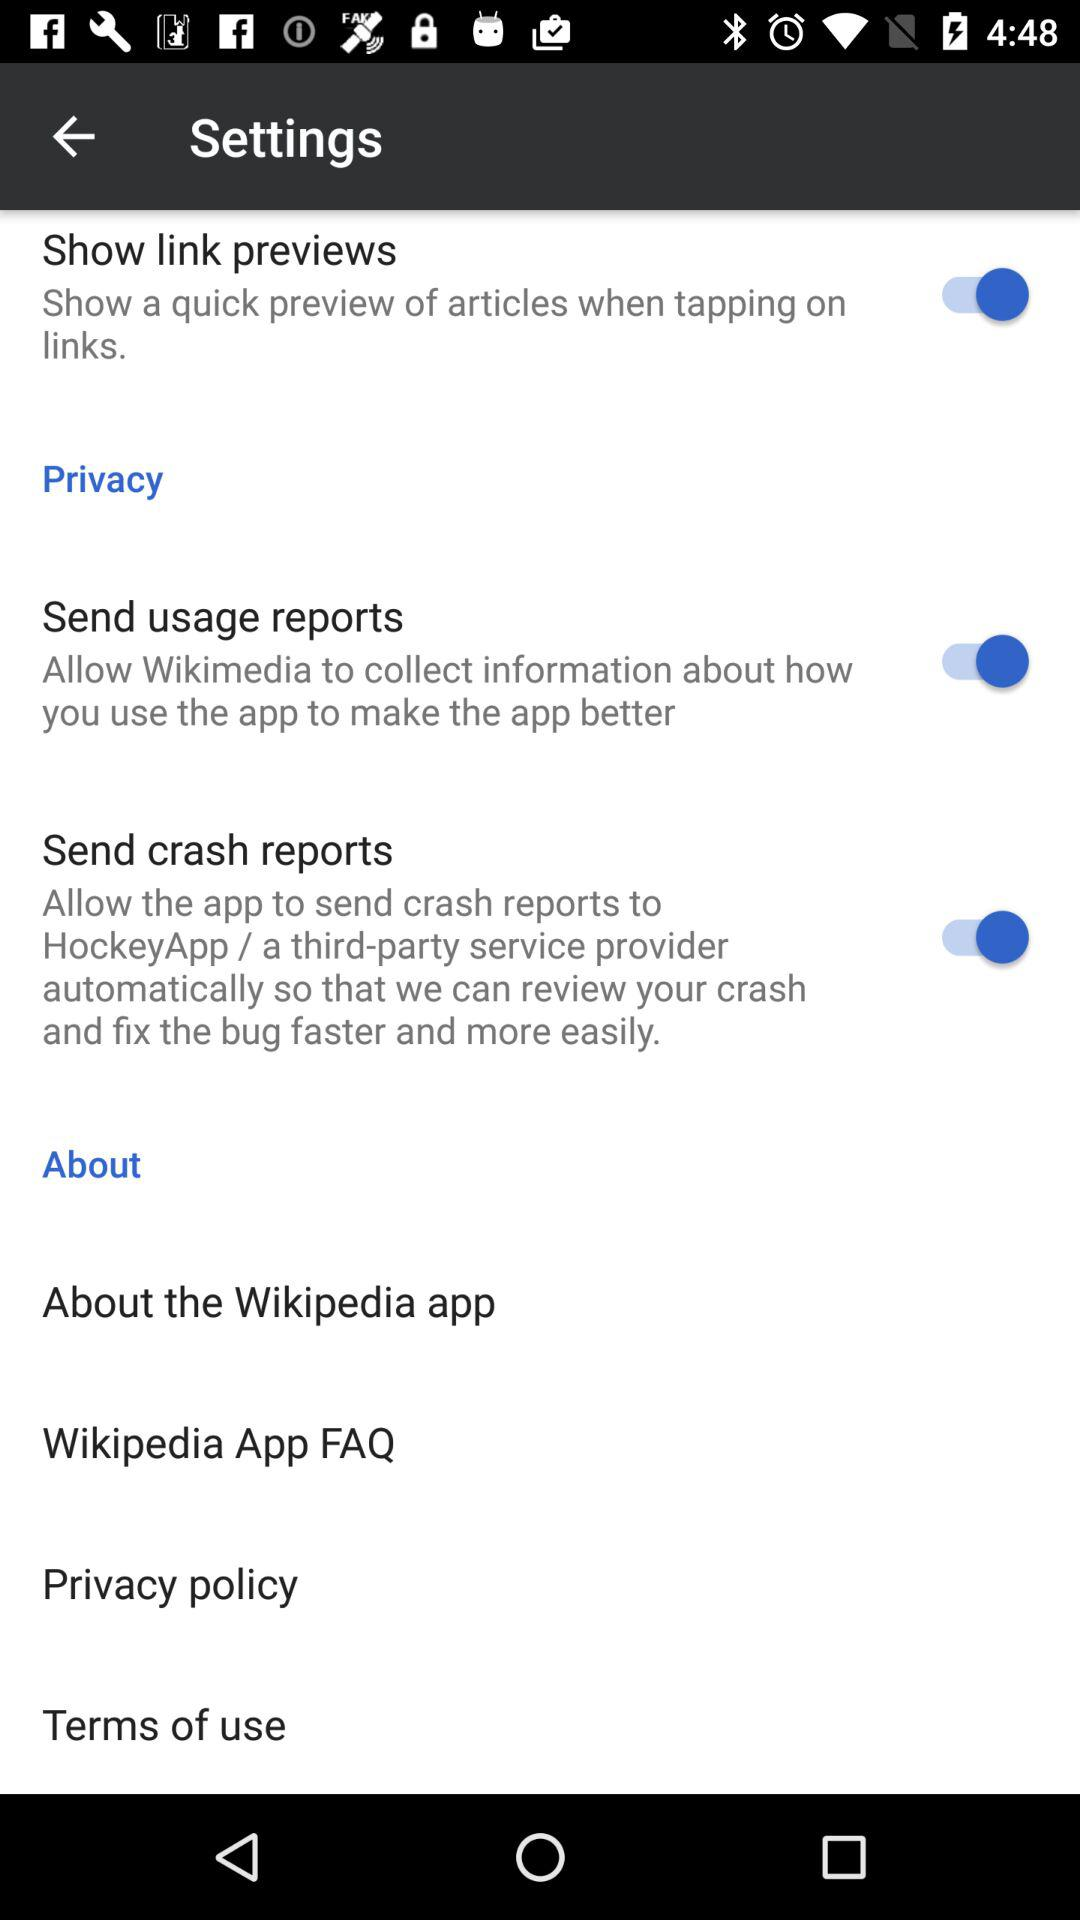What is the status of the "Show link previews"? The status of the "Show link previews" is "on". 